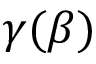<formula> <loc_0><loc_0><loc_500><loc_500>\gamma ( \beta )</formula> 